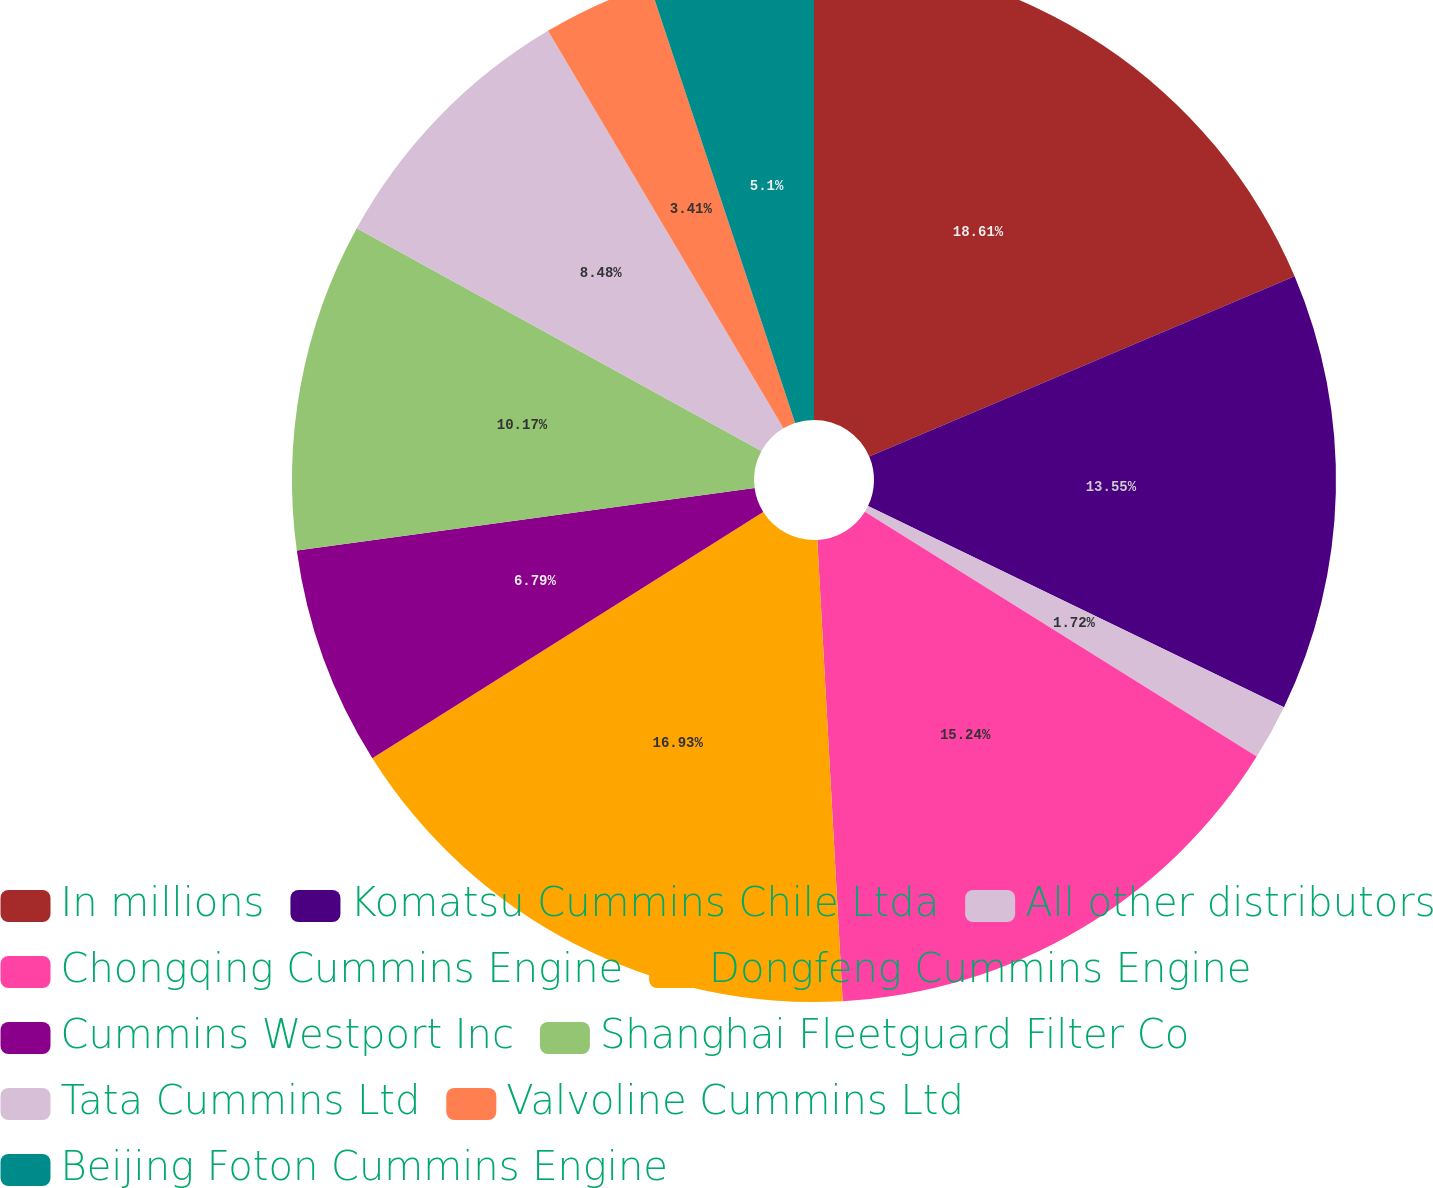Convert chart. <chart><loc_0><loc_0><loc_500><loc_500><pie_chart><fcel>In millions<fcel>Komatsu Cummins Chile Ltda<fcel>All other distributors<fcel>Chongqing Cummins Engine<fcel>Dongfeng Cummins Engine<fcel>Cummins Westport Inc<fcel>Shanghai Fleetguard Filter Co<fcel>Tata Cummins Ltd<fcel>Valvoline Cummins Ltd<fcel>Beijing Foton Cummins Engine<nl><fcel>18.62%<fcel>13.55%<fcel>1.72%<fcel>15.24%<fcel>16.93%<fcel>6.79%<fcel>10.17%<fcel>8.48%<fcel>3.41%<fcel>5.1%<nl></chart> 